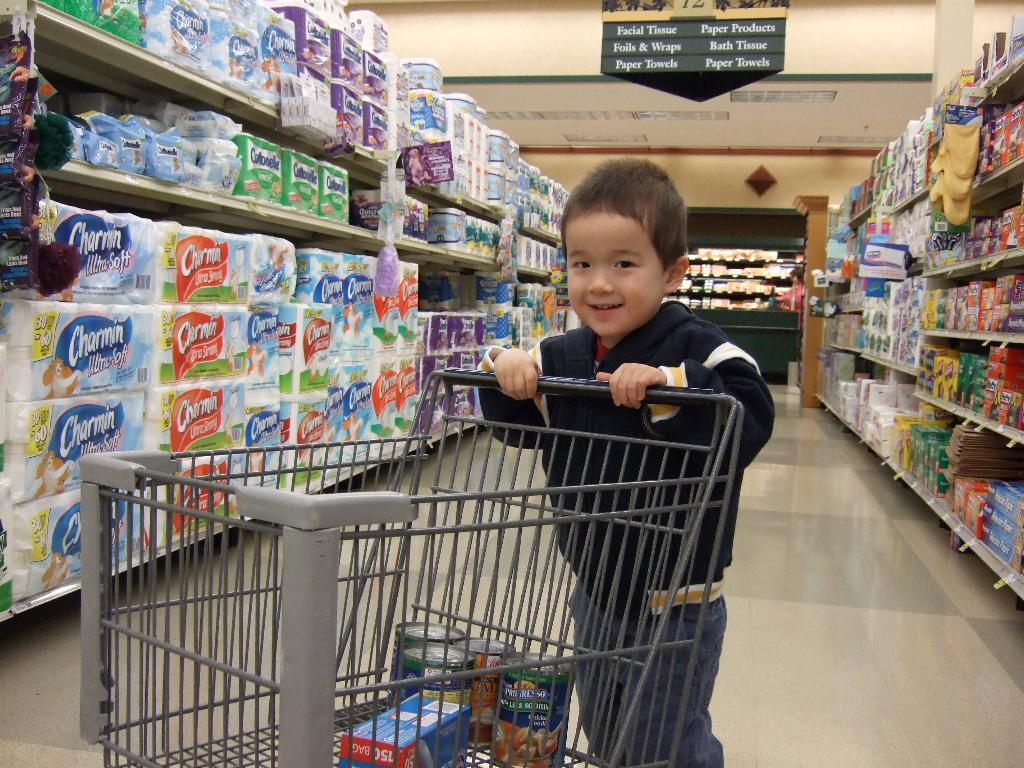Provide a one-sentence caption for the provided image. A boy is pushing a shopping cart in a grocery isle with Charmin toilet paper. 